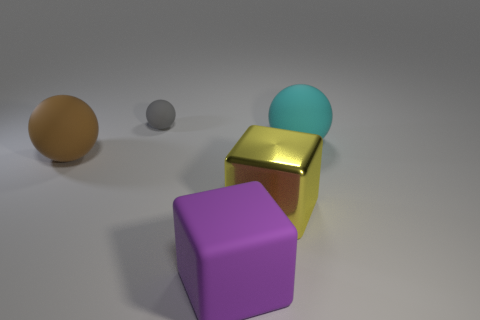Add 4 large yellow things. How many objects exist? 9 Subtract all blocks. How many objects are left? 3 Subtract 1 brown balls. How many objects are left? 4 Subtract all purple things. Subtract all big brown spheres. How many objects are left? 3 Add 3 matte spheres. How many matte spheres are left? 6 Add 4 metallic things. How many metallic things exist? 5 